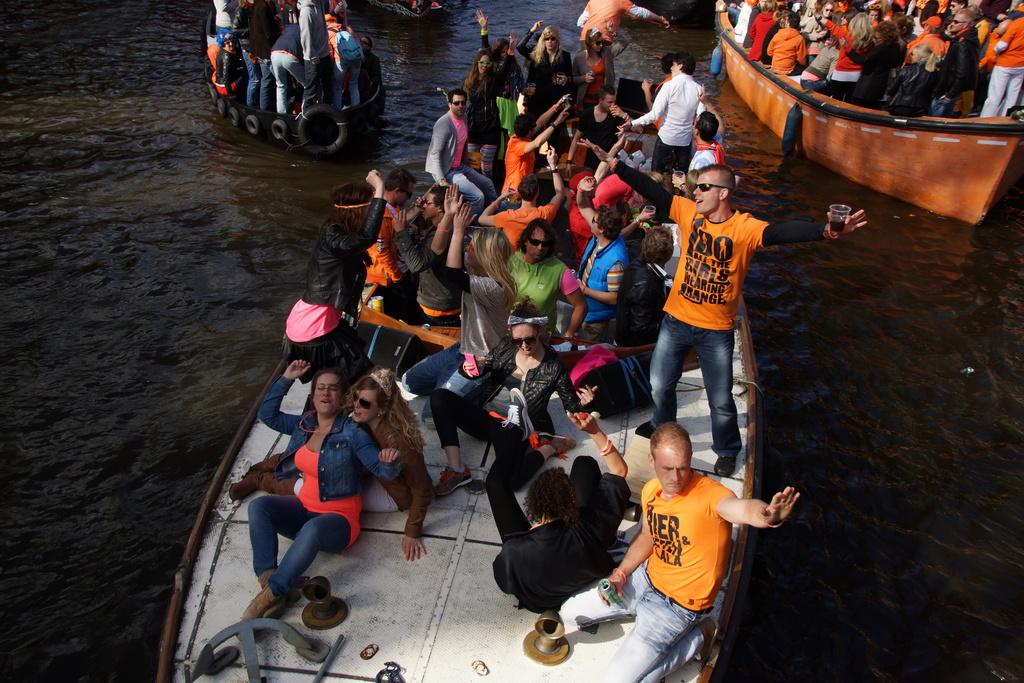What are the people doing on the boats in the image? There are groups of people on the boats, and some people are standing while others are sitting. How are the boats moving in the image? The boats are moving on the water. What are the inflatable water tubes used for in the image? The inflatable water tubes are hanging from the boats, possibly for recreational purposes. Are the parents of the people on the boats present in the image? There is no information about the parents of the people on the boats in the image. Can you tell me if the boats are on a lake or a river? The image does not provide enough information to determine whether the boats are on a lake or a river. 